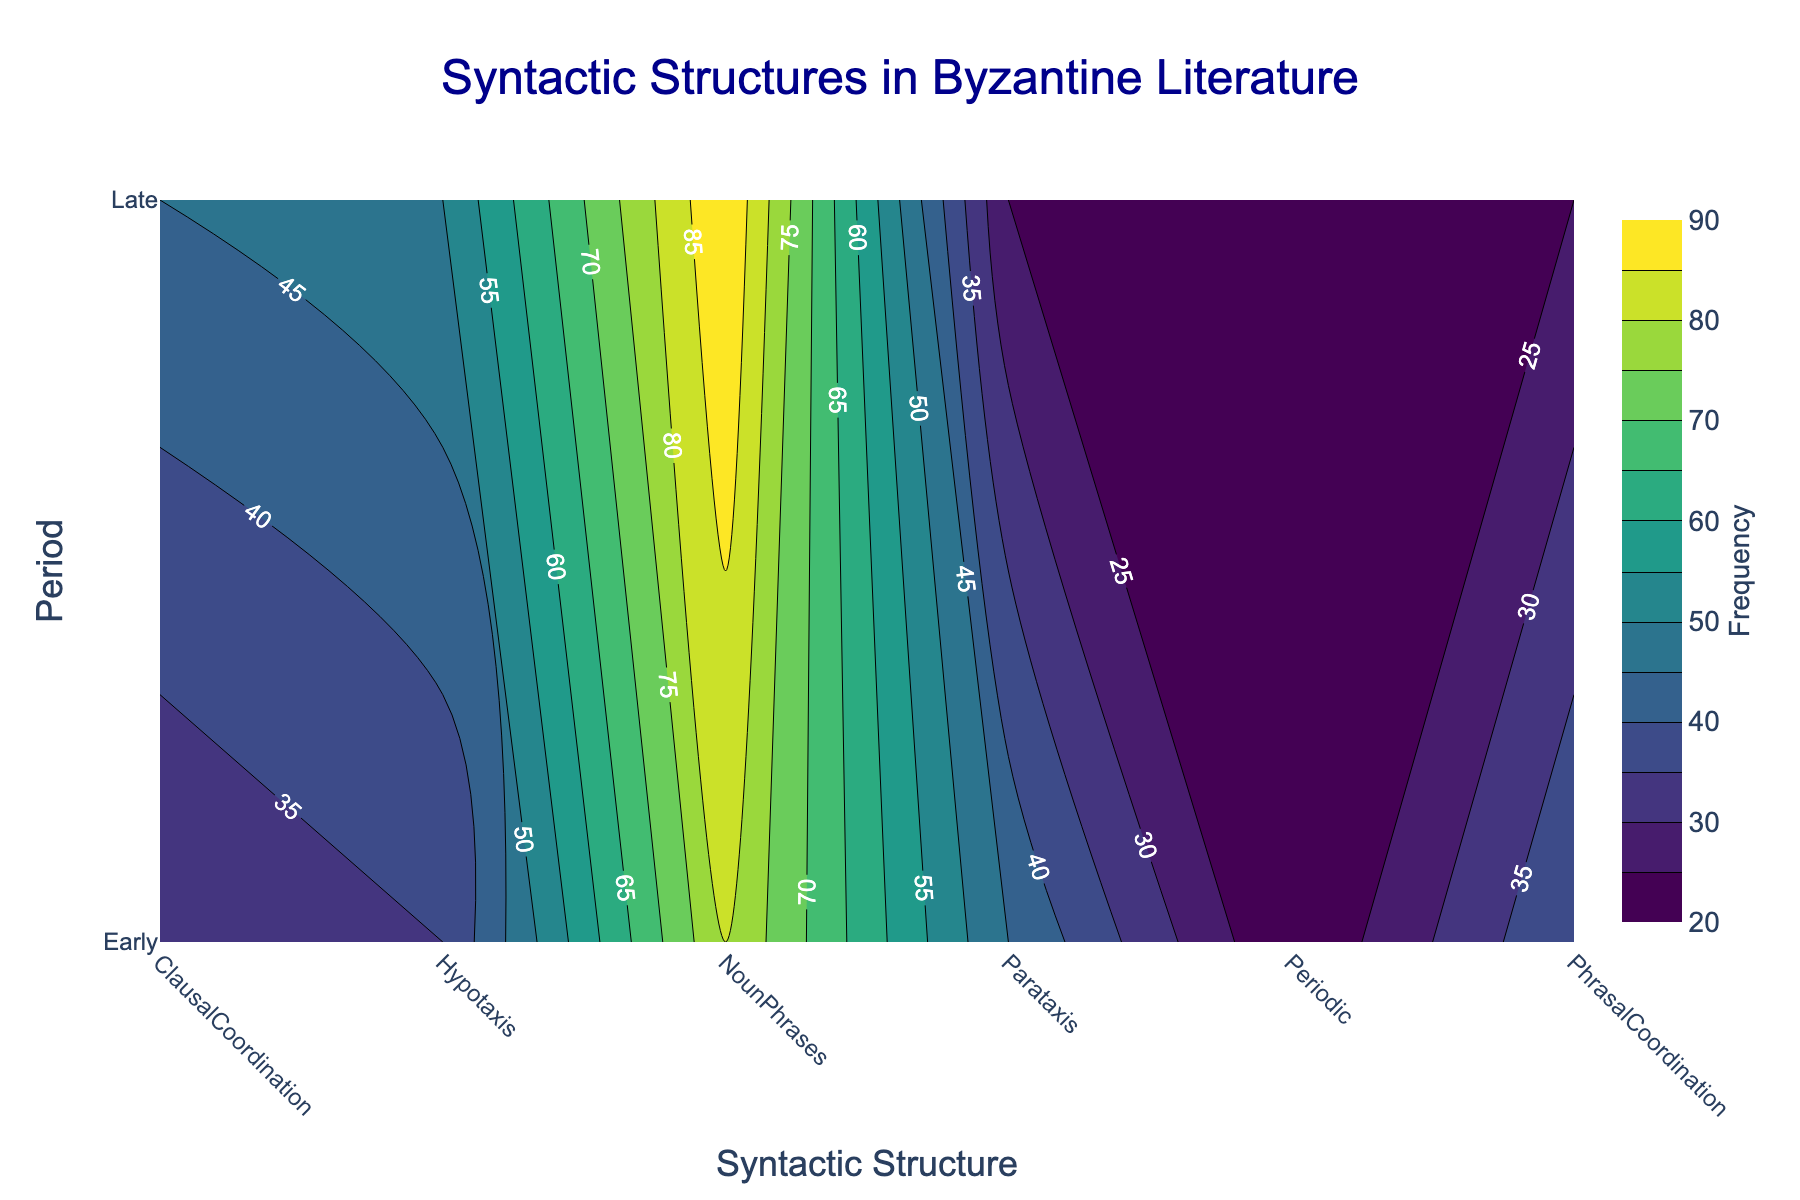What's the title of the figure? The title is positioned at the top of the plot. It explains the general content of the plot, which is about syntactic structures in Byzantine literature.
Answer: Syntactic Structures in Byzantine Literature Which period shows a higher frequency of Hypotaxis? To determine this, look at the contour values for Hypotaxis across the Early and Late periods.
Answer: Late What's the lowest frequency value and for which structure and period is it? The lowest contour value indicates the structure and period with the least frequency.
Answer: Periodic, Early Compare the frequencies of Parataxis in Early and Late periods. Which period has a higher frequency and by how much? Inspect the contour values for Parataxis in both periods. Subtract the Late period value from the Early period value to find the difference.
Answer: Early by 20 What is the total frequency of Noun Phrases across both periods? Find the frequency values for Noun Phrases in both periods and sum them up: 80 (Early) + 90 (Late).
Answer: 170 What is the average frequency of structures in the Late period? Add the frequencies for all structures in the Late period and divide by the number of structures: (25 + 50 + 25 + 25 + 45 + 90) / 6.
Answer: 43.33 Is there a structure with the same frequency across both periods? Look for any structure in the contour plot that has matching values for both the Early and Late periods.
Answer: Yes, Periodic Which structure has the highest frequency in the Early period? Look at the contour values for all structures in the Early period and determine the highest value.
Answer: Noun Phrases 